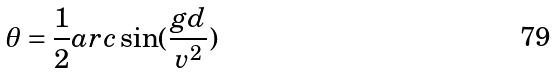<formula> <loc_0><loc_0><loc_500><loc_500>\theta = \frac { 1 } { 2 } a r c \sin ( \frac { g d } { v ^ { 2 } } )</formula> 